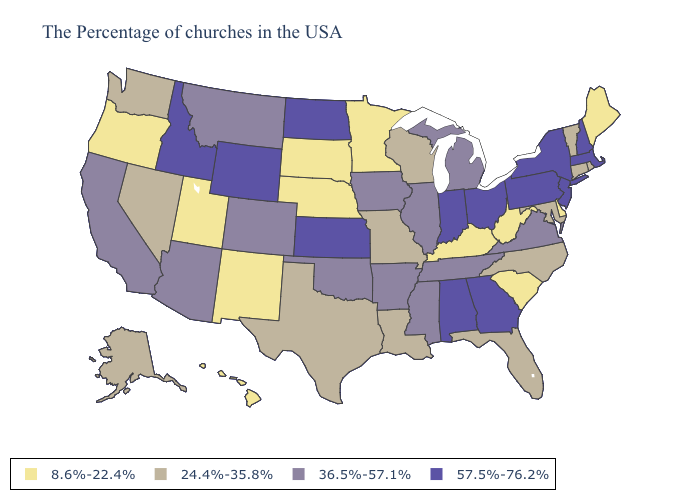Name the states that have a value in the range 24.4%-35.8%?
Answer briefly. Rhode Island, Vermont, Connecticut, Maryland, North Carolina, Florida, Wisconsin, Louisiana, Missouri, Texas, Nevada, Washington, Alaska. Which states hav the highest value in the South?
Be succinct. Georgia, Alabama. Name the states that have a value in the range 36.5%-57.1%?
Answer briefly. Virginia, Michigan, Tennessee, Illinois, Mississippi, Arkansas, Iowa, Oklahoma, Colorado, Montana, Arizona, California. What is the value of Michigan?
Write a very short answer. 36.5%-57.1%. What is the value of Kansas?
Give a very brief answer. 57.5%-76.2%. What is the value of Missouri?
Be succinct. 24.4%-35.8%. Name the states that have a value in the range 36.5%-57.1%?
Write a very short answer. Virginia, Michigan, Tennessee, Illinois, Mississippi, Arkansas, Iowa, Oklahoma, Colorado, Montana, Arizona, California. Is the legend a continuous bar?
Give a very brief answer. No. Name the states that have a value in the range 36.5%-57.1%?
Short answer required. Virginia, Michigan, Tennessee, Illinois, Mississippi, Arkansas, Iowa, Oklahoma, Colorado, Montana, Arizona, California. Does Idaho have a higher value than Montana?
Short answer required. Yes. Does Idaho have the highest value in the USA?
Be succinct. Yes. What is the lowest value in the MidWest?
Write a very short answer. 8.6%-22.4%. Does Texas have a lower value than Kentucky?
Short answer required. No. Among the states that border Nevada , does California have the highest value?
Concise answer only. No. Among the states that border New Mexico , does Oklahoma have the highest value?
Quick response, please. Yes. 